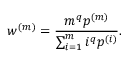Convert formula to latex. <formula><loc_0><loc_0><loc_500><loc_500>w ^ { ( m ) } = \frac { m ^ { q } p ^ { ( m ) } } { \sum _ { i = 1 } ^ { m } i ^ { q } p ^ { ( i ) } } .</formula> 